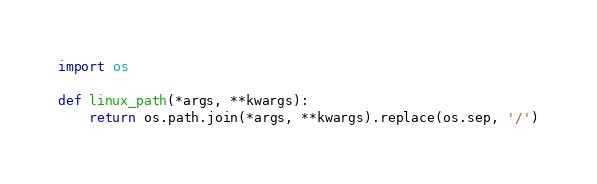<code> <loc_0><loc_0><loc_500><loc_500><_Python_>import os

def linux_path(*args, **kwargs):
    return os.path.join(*args, **kwargs).replace(os.sep, '/')

</code> 